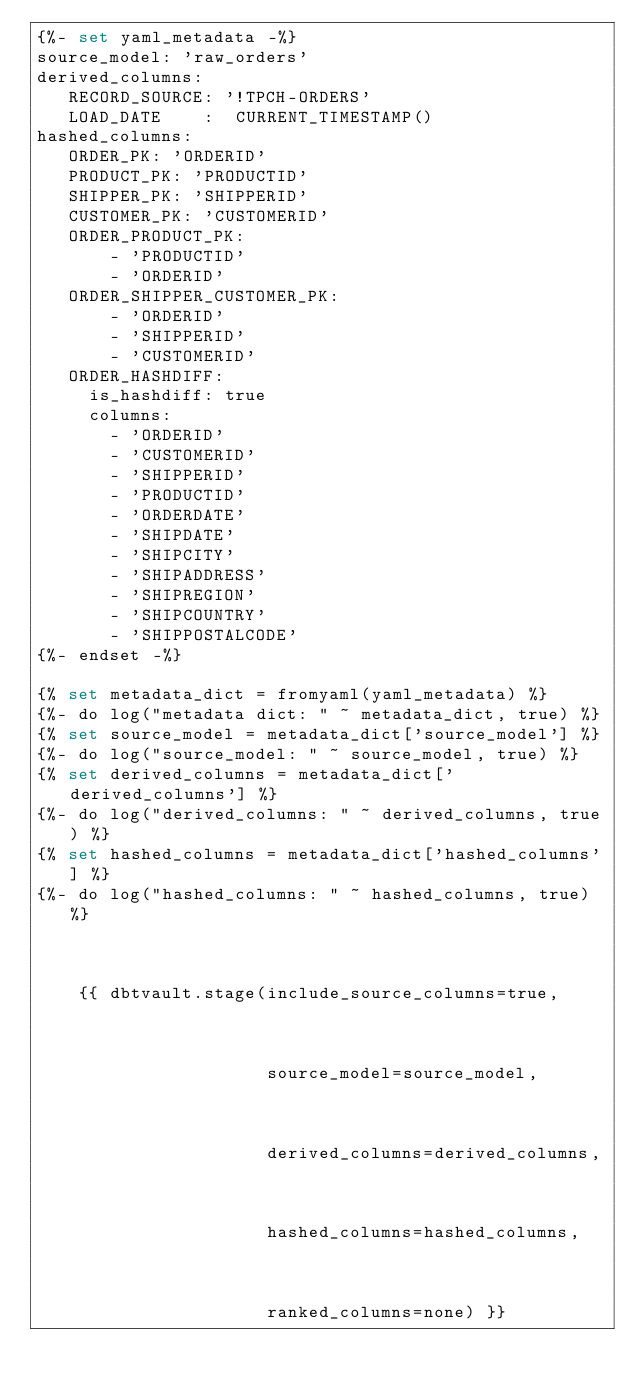Convert code to text. <code><loc_0><loc_0><loc_500><loc_500><_SQL_>{%- set yaml_metadata -%}
source_model: 'raw_orders'
derived_columns:
   RECORD_SOURCE: '!TPCH-ORDERS'
   LOAD_DATE    :  CURRENT_TIMESTAMP()
hashed_columns:
   ORDER_PK: 'ORDERID'
   PRODUCT_PK: 'PRODUCTID'
   SHIPPER_PK: 'SHIPPERID'
   CUSTOMER_PK: 'CUSTOMERID'
   ORDER_PRODUCT_PK:
       - 'PRODUCTID'
       - 'ORDERID'
   ORDER_SHIPPER_CUSTOMER_PK:
       - 'ORDERID'
       - 'SHIPPERID'
       - 'CUSTOMERID'
   ORDER_HASHDIFF:
     is_hashdiff: true
     columns:
       - 'ORDERID'
       - 'CUSTOMERID'
       - 'SHIPPERID'
       - 'PRODUCTID'
       - 'ORDERDATE'
       - 'SHIPDATE'
       - 'SHIPCITY'
       - 'SHIPADDRESS'
       - 'SHIPREGION'
       - 'SHIPCOUNTRY'
       - 'SHIPPOSTALCODE'
{%- endset -%}

{% set metadata_dict = fromyaml(yaml_metadata) %}
{%- do log("metadata dict: " ~ metadata_dict, true) %}
{% set source_model = metadata_dict['source_model'] %}
{%- do log("source_model: " ~ source_model, true) %}
{% set derived_columns = metadata_dict['derived_columns'] %}
{%- do log("derived_columns: " ~ derived_columns, true) %}
{% set hashed_columns = metadata_dict['hashed_columns'] %}
{%- do log("hashed_columns: " ~ hashed_columns, true) %}



    {{ dbtvault.stage(include_source_columns=true,



                      source_model=source_model,



                      derived_columns=derived_columns,



                      hashed_columns=hashed_columns,



                      ranked_columns=none) }}


</code> 